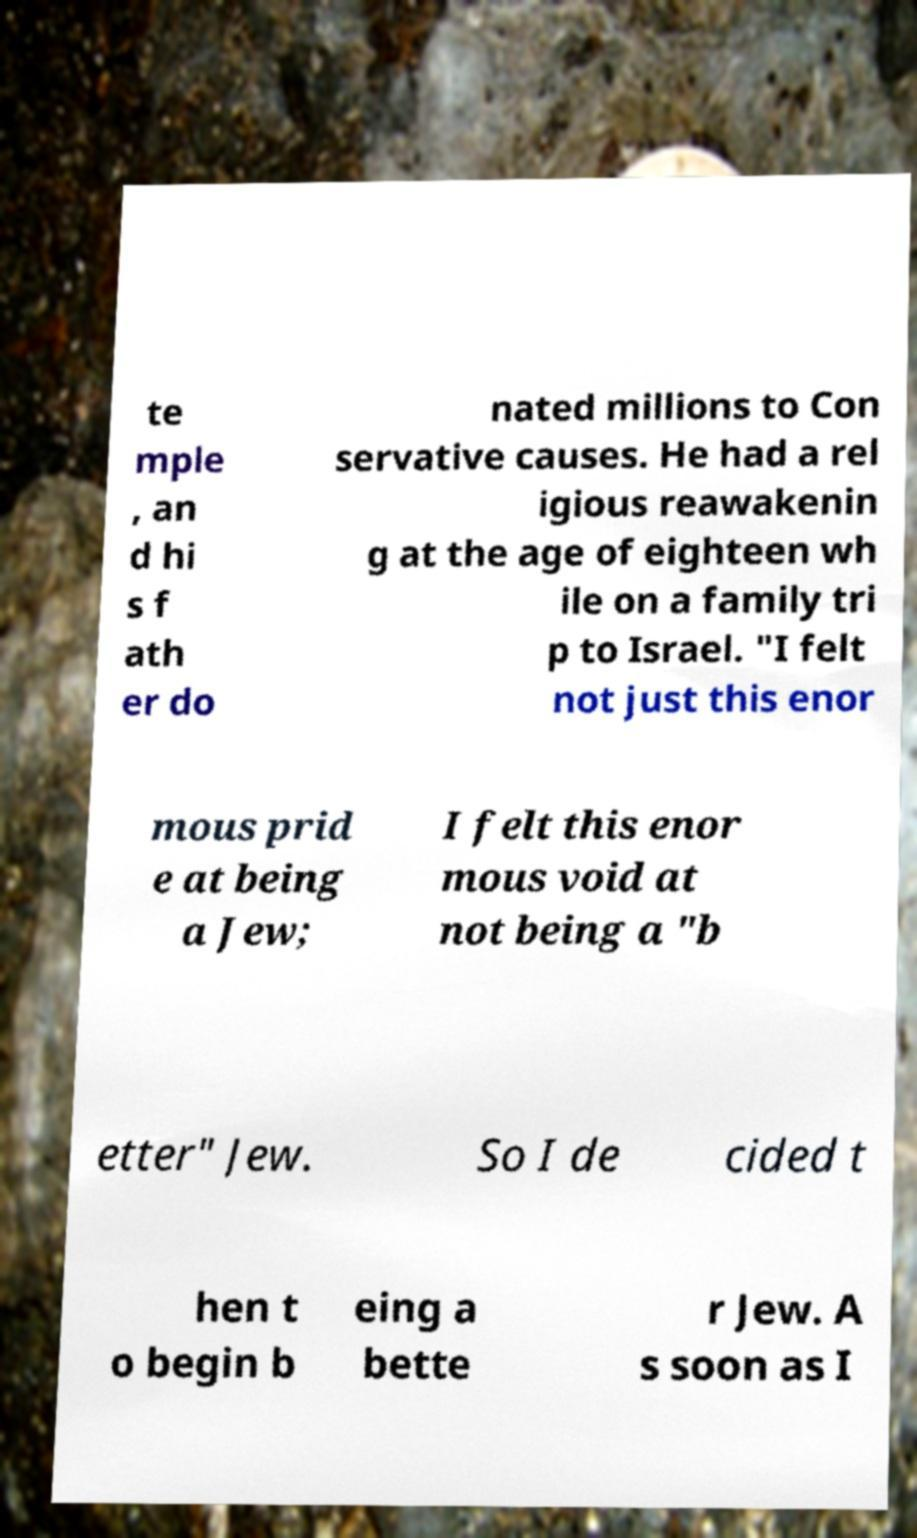Can you accurately transcribe the text from the provided image for me? te mple , an d hi s f ath er do nated millions to Con servative causes. He had a rel igious reawakenin g at the age of eighteen wh ile on a family tri p to Israel. "I felt not just this enor mous prid e at being a Jew; I felt this enor mous void at not being a "b etter" Jew. So I de cided t hen t o begin b eing a bette r Jew. A s soon as I 